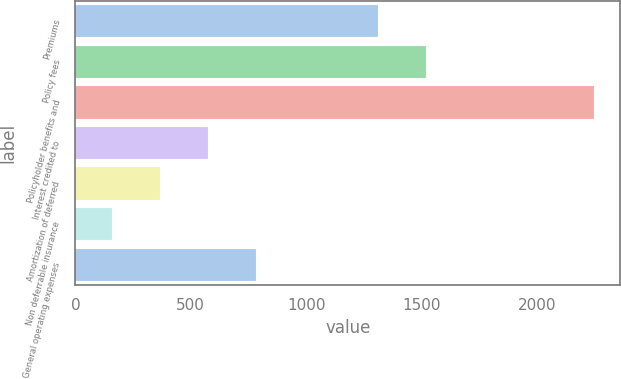<chart> <loc_0><loc_0><loc_500><loc_500><bar_chart><fcel>Premiums<fcel>Policy fees<fcel>Policyholder benefits and<fcel>Interest credited to<fcel>Amortization of deferred<fcel>Non deferrable insurance<fcel>General operating expenses<nl><fcel>1311<fcel>1520.1<fcel>2248<fcel>575.2<fcel>366.1<fcel>157<fcel>784.3<nl></chart> 